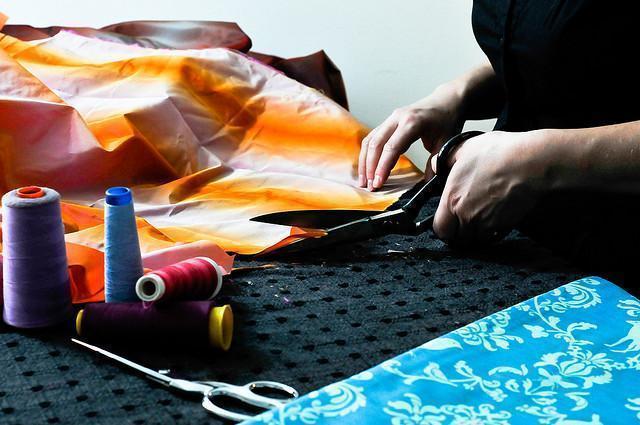What item does the person cut?
Make your selection from the four choices given to correctly answer the question.
Options: Cloth, paper, markers, chalk. Cloth. 